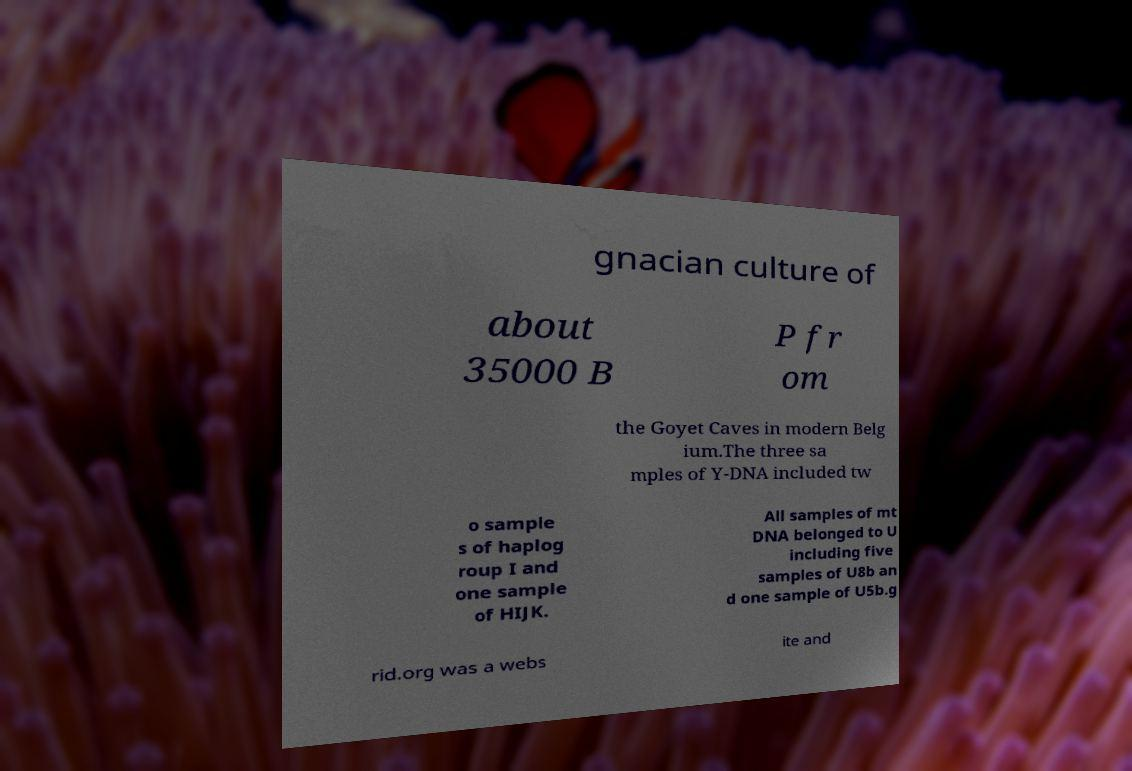Please identify and transcribe the text found in this image. gnacian culture of about 35000 B P fr om the Goyet Caves in modern Belg ium.The three sa mples of Y-DNA included tw o sample s of haplog roup I and one sample of HIJK. All samples of mt DNA belonged to U including five samples of U8b an d one sample of U5b.g rid.org was a webs ite and 